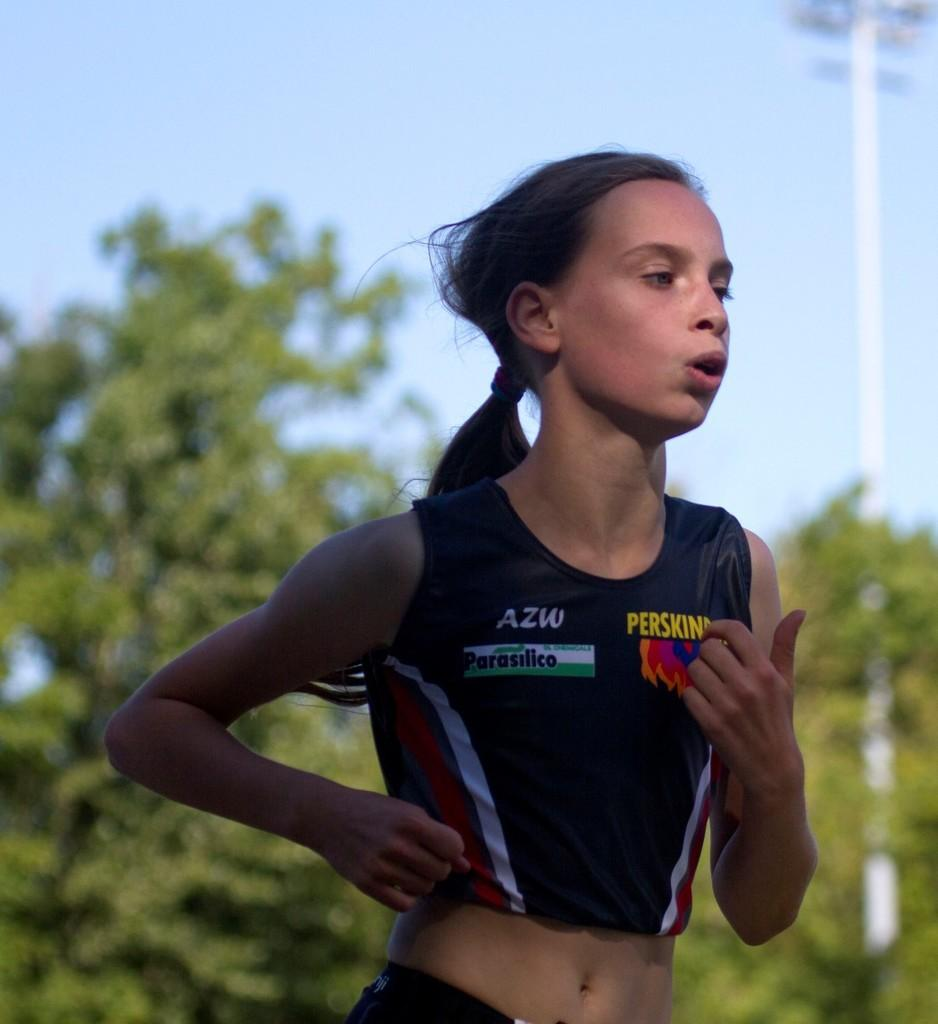Who is the main subject in the image? There is a girl in the image. What is the girl doing in the image? The girl is running. What is the girl wearing in the image? The girl is wearing a black top. What can be seen in the background of the image? There is a tree, a pole with lights, and the sky visible in the background of the image. What type of arithmetic problem is the girl solving while running in the image? There is no indication in the image that the girl is solving an arithmetic problem while running. 